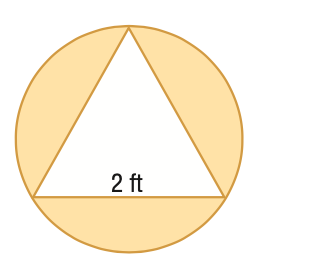Question: Find the area of the shaded region formed by the circle and regular polygon. Round to the nearest tenth.
Choices:
A. 0.7
B. 2.5
C. 6.6
D. 15.0
Answer with the letter. Answer: B 